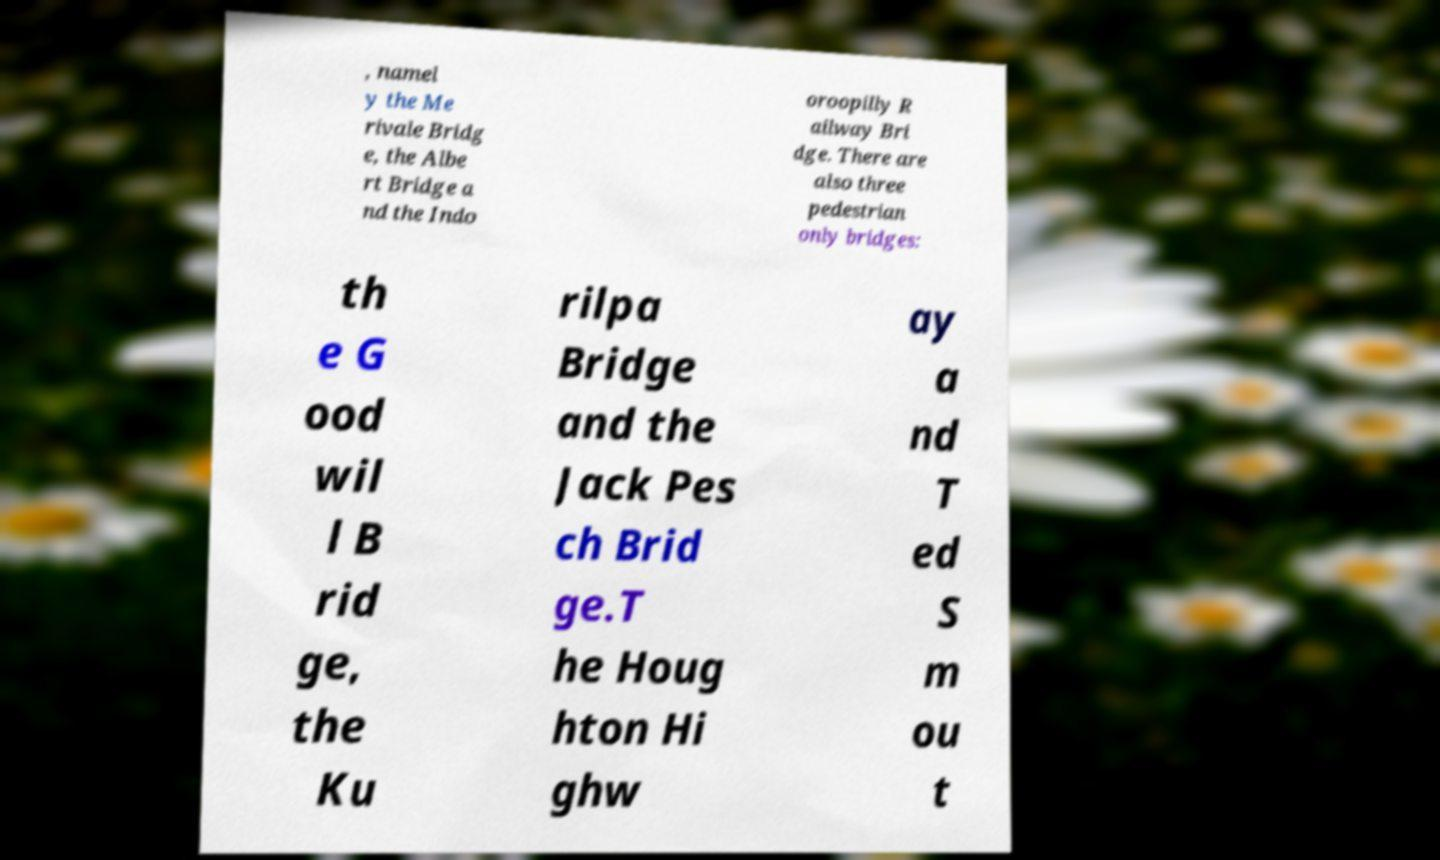Can you read and provide the text displayed in the image?This photo seems to have some interesting text. Can you extract and type it out for me? , namel y the Me rivale Bridg e, the Albe rt Bridge a nd the Indo oroopilly R ailway Bri dge. There are also three pedestrian only bridges: th e G ood wil l B rid ge, the Ku rilpa Bridge and the Jack Pes ch Brid ge.T he Houg hton Hi ghw ay a nd T ed S m ou t 